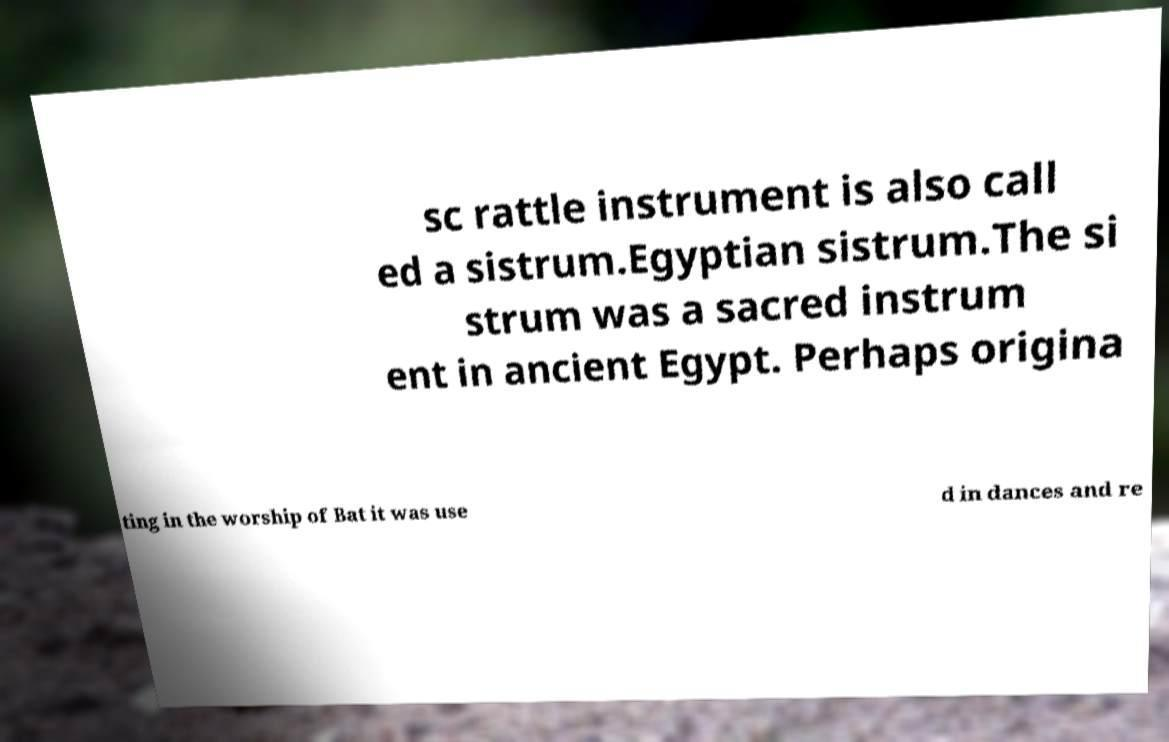What messages or text are displayed in this image? I need them in a readable, typed format. sc rattle instrument is also call ed a sistrum.Egyptian sistrum.The si strum was a sacred instrum ent in ancient Egypt. Perhaps origina ting in the worship of Bat it was use d in dances and re 